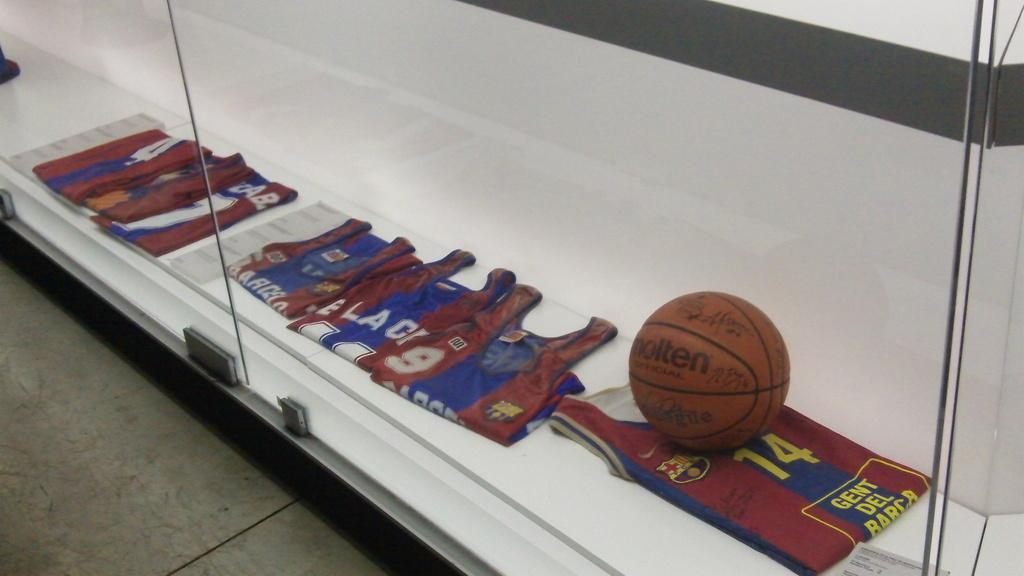<image>
Describe the image concisely. A glass display case holds several jerseys including a number 14 jersey and a basketball. 